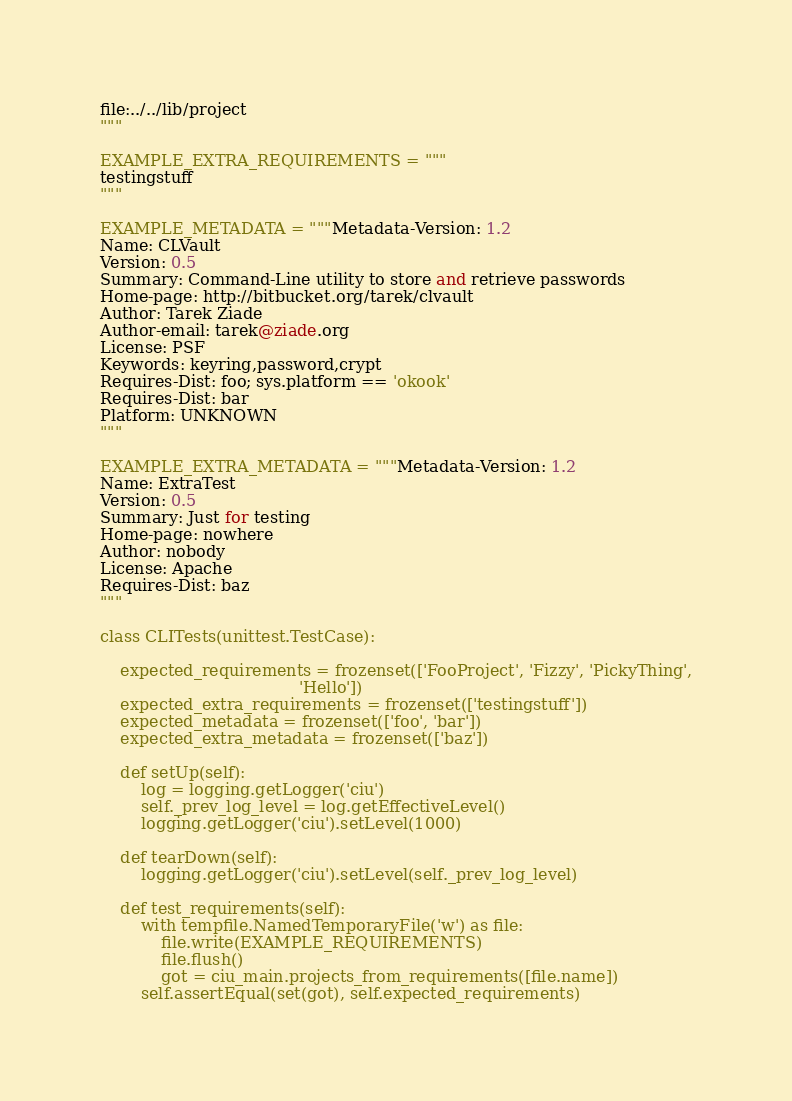<code> <loc_0><loc_0><loc_500><loc_500><_Python_>file:../../lib/project
"""

EXAMPLE_EXTRA_REQUIREMENTS = """
testingstuff
"""

EXAMPLE_METADATA = """Metadata-Version: 1.2
Name: CLVault
Version: 0.5
Summary: Command-Line utility to store and retrieve passwords
Home-page: http://bitbucket.org/tarek/clvault
Author: Tarek Ziade
Author-email: tarek@ziade.org
License: PSF
Keywords: keyring,password,crypt
Requires-Dist: foo; sys.platform == 'okook'
Requires-Dist: bar
Platform: UNKNOWN
"""

EXAMPLE_EXTRA_METADATA = """Metadata-Version: 1.2
Name: ExtraTest
Version: 0.5
Summary: Just for testing
Home-page: nowhere
Author: nobody
License: Apache
Requires-Dist: baz
"""

class CLITests(unittest.TestCase):

    expected_requirements = frozenset(['FooProject', 'Fizzy', 'PickyThing',
                                       'Hello'])
    expected_extra_requirements = frozenset(['testingstuff'])
    expected_metadata = frozenset(['foo', 'bar'])
    expected_extra_metadata = frozenset(['baz'])

    def setUp(self):
        log = logging.getLogger('ciu')
        self._prev_log_level = log.getEffectiveLevel()
        logging.getLogger('ciu').setLevel(1000)

    def tearDown(self):
        logging.getLogger('ciu').setLevel(self._prev_log_level)

    def test_requirements(self):
        with tempfile.NamedTemporaryFile('w') as file:
            file.write(EXAMPLE_REQUIREMENTS)
            file.flush()
            got = ciu_main.projects_from_requirements([file.name])
        self.assertEqual(set(got), self.expected_requirements)
</code> 